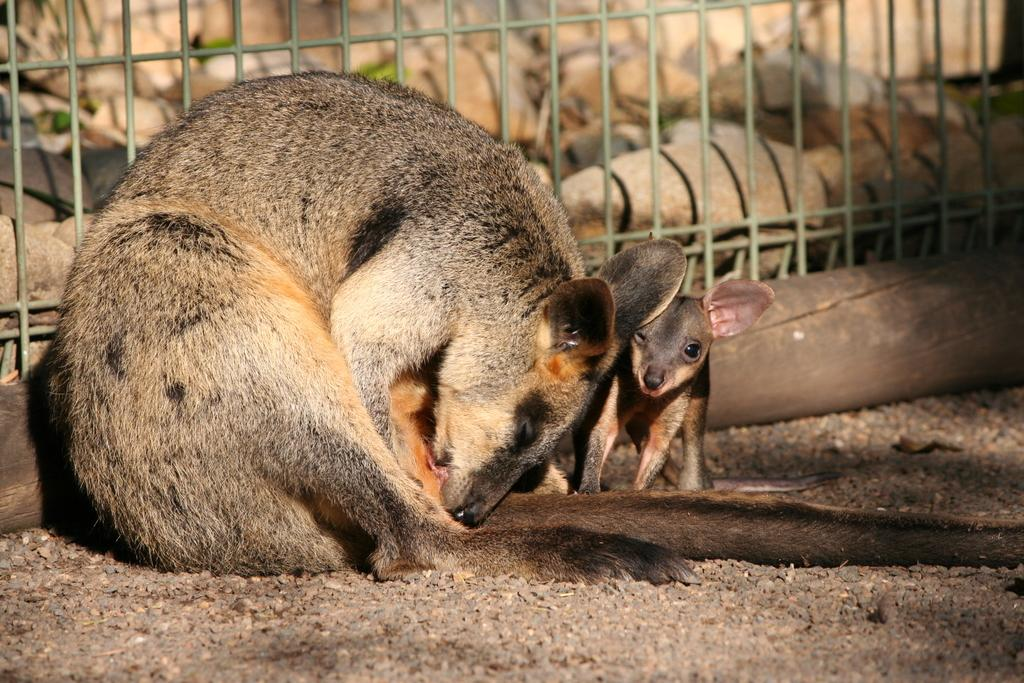What types of living organisms are present in the image? There are animals in the image. What are the animals doing in the image? The animals are in front of grills. Can you describe any other objects or structures in the image? There is a wooden pole on the ground in the image. What type of flight can be seen in the image? There is no flight present in the image; it features animals in front of grills and a wooden pole on the ground. What kind of reward is the animal receiving for its performance in the image? There is no performance or reward depicted in the image; it simply shows animals in front of grills and a wooden pole on the ground. 